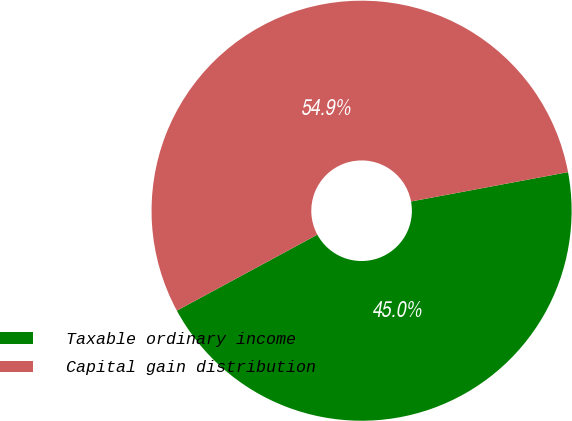<chart> <loc_0><loc_0><loc_500><loc_500><pie_chart><fcel>Taxable ordinary income<fcel>Capital gain distribution<nl><fcel>45.05%<fcel>54.95%<nl></chart> 